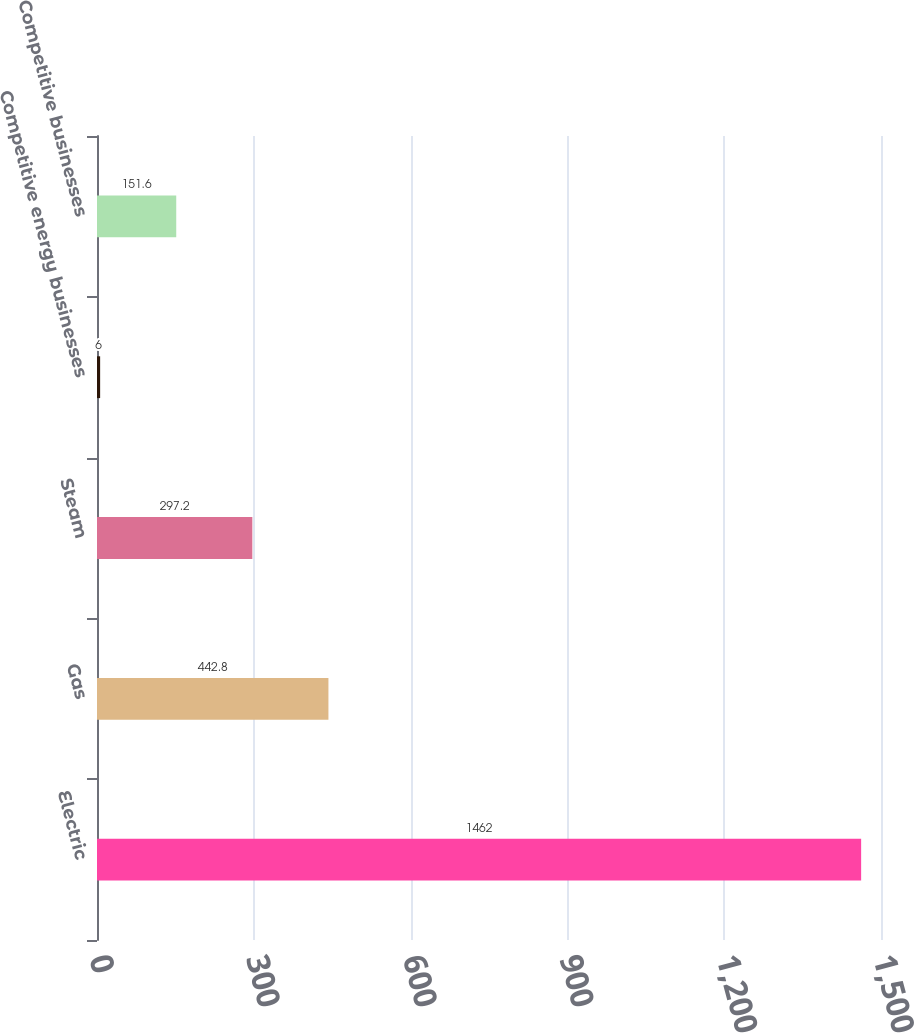<chart> <loc_0><loc_0><loc_500><loc_500><bar_chart><fcel>Electric<fcel>Gas<fcel>Steam<fcel>Competitive energy businesses<fcel>Competitive businesses<nl><fcel>1462<fcel>442.8<fcel>297.2<fcel>6<fcel>151.6<nl></chart> 